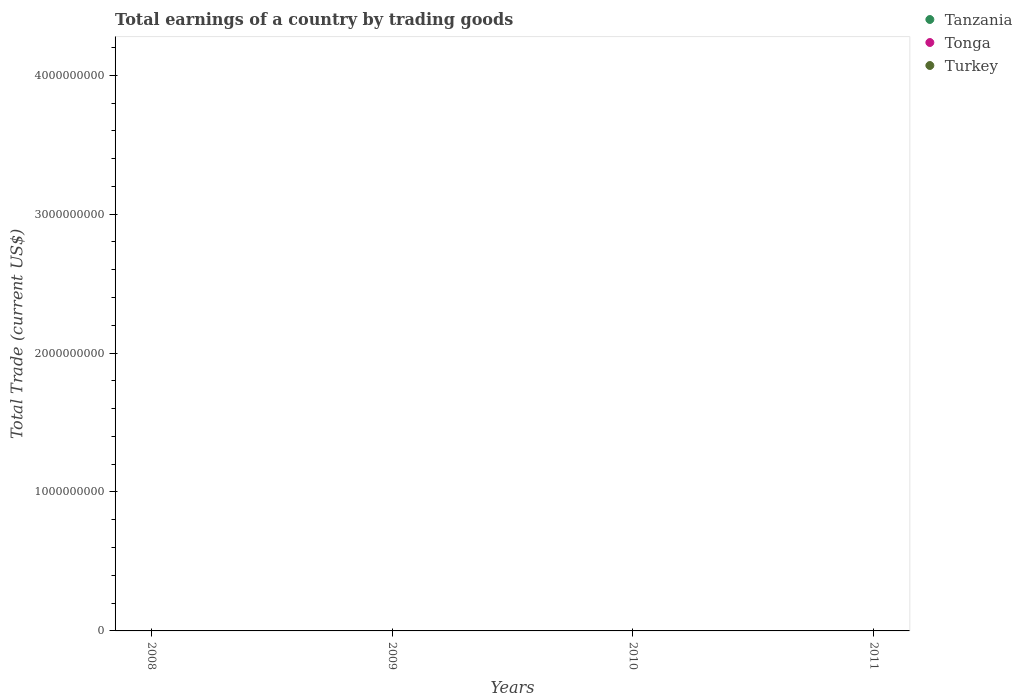How many different coloured dotlines are there?
Keep it short and to the point. 0. What is the difference between the total earnings in Tanzania in 2009 and the total earnings in Turkey in 2010?
Ensure brevity in your answer.  0. How many dotlines are there?
Provide a short and direct response. 0. Does the graph contain any zero values?
Your response must be concise. Yes. Where does the legend appear in the graph?
Provide a succinct answer. Top right. What is the title of the graph?
Your answer should be very brief. Total earnings of a country by trading goods. What is the label or title of the X-axis?
Ensure brevity in your answer.  Years. What is the label or title of the Y-axis?
Your answer should be very brief. Total Trade (current US$). What is the Total Trade (current US$) in Tanzania in 2008?
Keep it short and to the point. 0. What is the Total Trade (current US$) in Turkey in 2008?
Offer a terse response. 0. What is the Total Trade (current US$) in Tanzania in 2009?
Your answer should be compact. 0. What is the Total Trade (current US$) in Tonga in 2009?
Keep it short and to the point. 0. What is the Total Trade (current US$) of Turkey in 2009?
Keep it short and to the point. 0. What is the Total Trade (current US$) of Tanzania in 2010?
Offer a very short reply. 0. What is the Total Trade (current US$) in Turkey in 2010?
Your answer should be compact. 0. What is the Total Trade (current US$) in Tonga in 2011?
Ensure brevity in your answer.  0. What is the Total Trade (current US$) of Turkey in 2011?
Provide a short and direct response. 0. What is the total Total Trade (current US$) in Tanzania in the graph?
Offer a terse response. 0. What is the total Total Trade (current US$) of Turkey in the graph?
Offer a very short reply. 0. What is the average Total Trade (current US$) of Turkey per year?
Offer a very short reply. 0. 